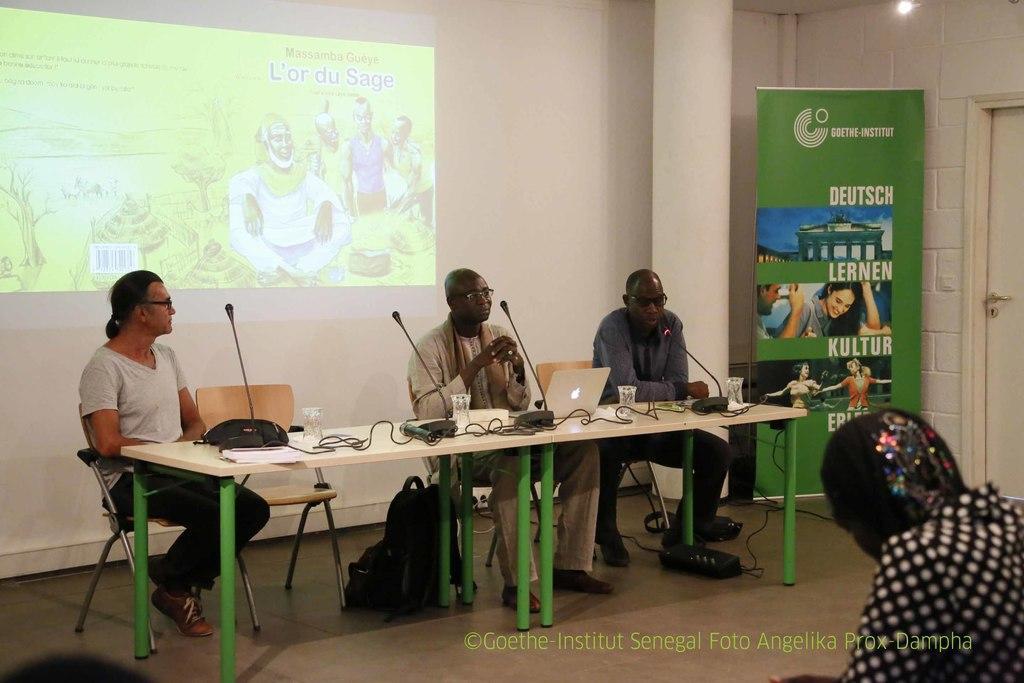In one or two sentences, can you explain what this image depicts? In the image we can see there are people who are sitting on chair. 